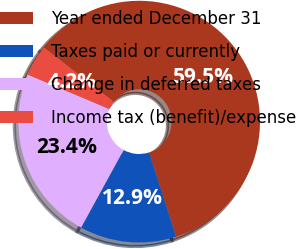Convert chart to OTSL. <chart><loc_0><loc_0><loc_500><loc_500><pie_chart><fcel>Year ended December 31<fcel>Taxes paid or currently<fcel>Change in deferred taxes<fcel>Income tax (benefit)/expense<nl><fcel>59.54%<fcel>12.92%<fcel>23.38%<fcel>4.16%<nl></chart> 